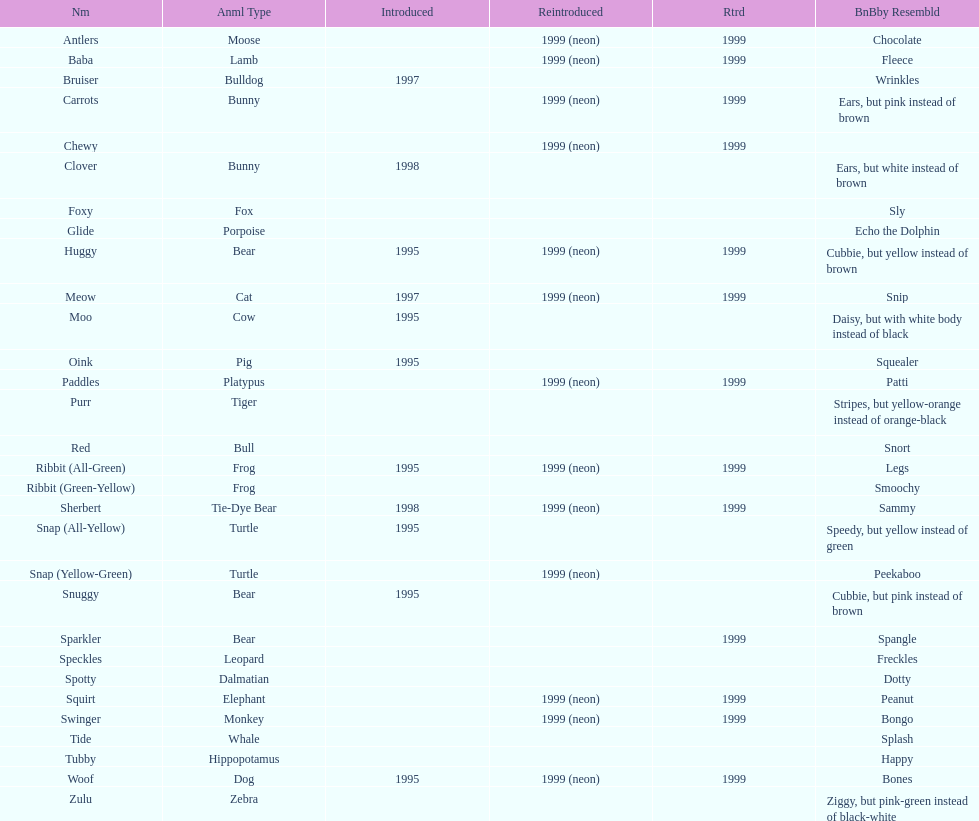What is the name of the last pillow pal on this chart? Zulu. 